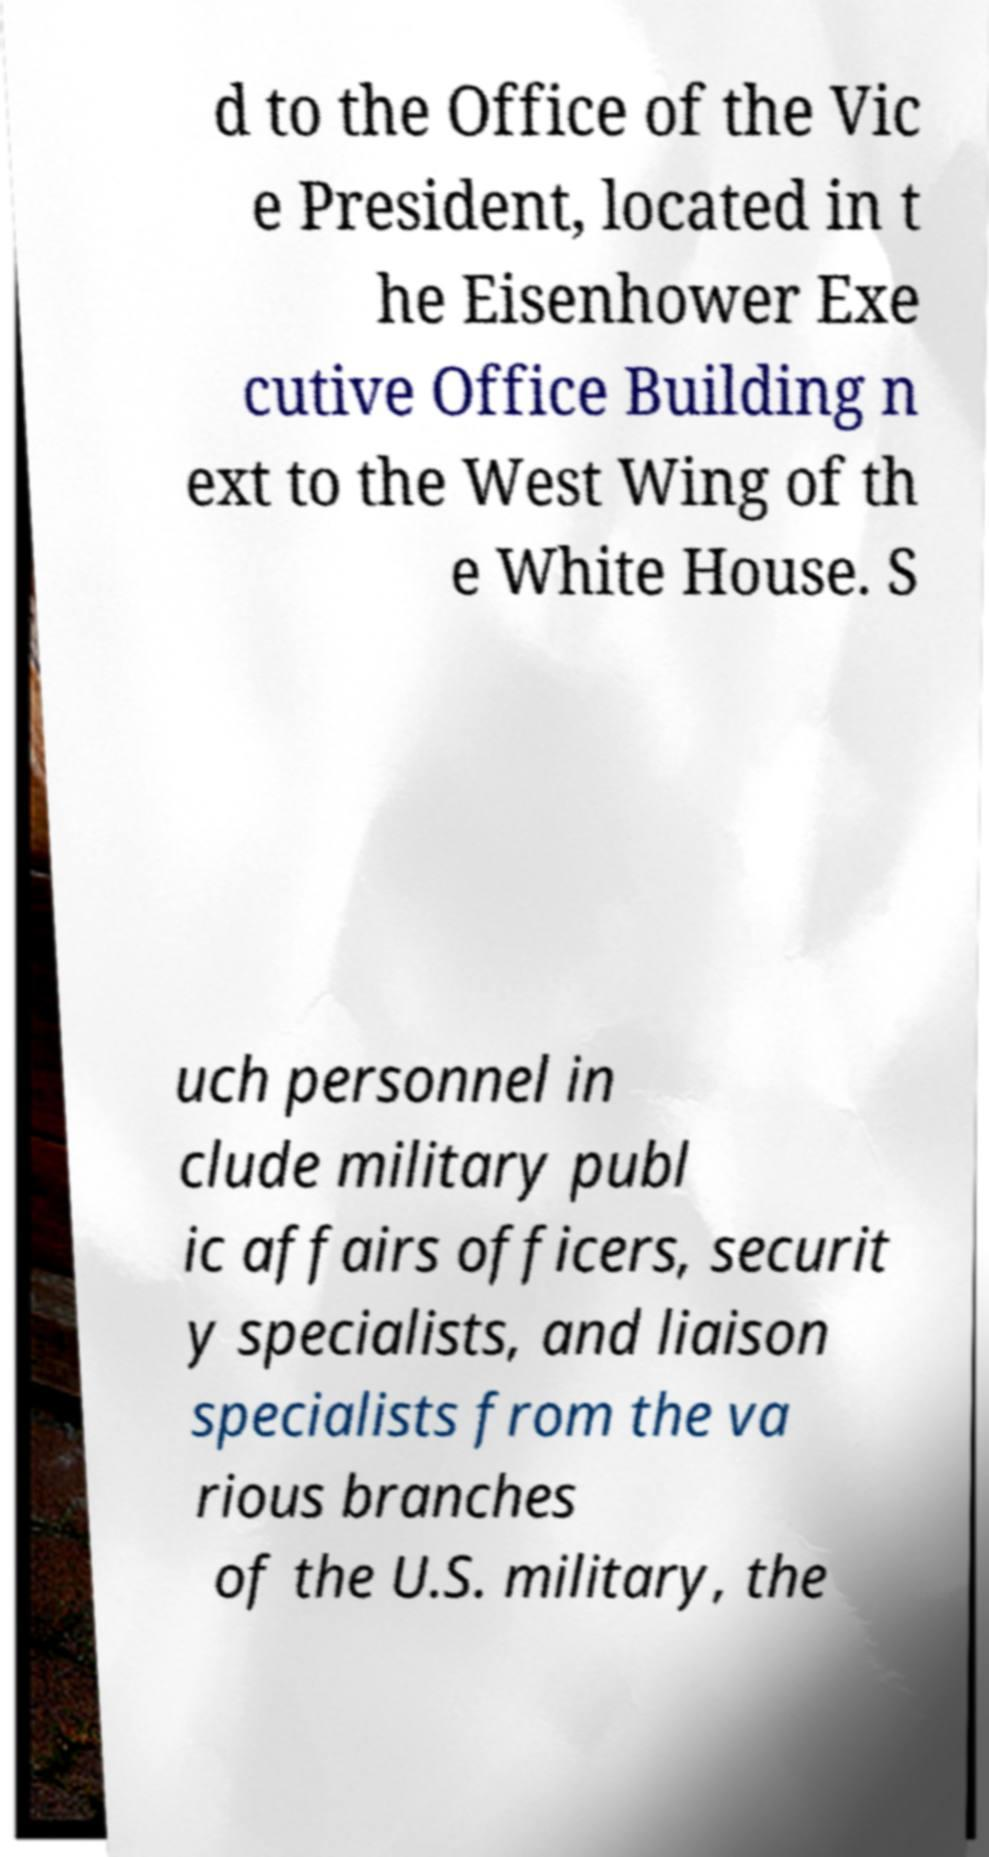What messages or text are displayed in this image? I need them in a readable, typed format. d to the Office of the Vic e President, located in t he Eisenhower Exe cutive Office Building n ext to the West Wing of th e White House. S uch personnel in clude military publ ic affairs officers, securit y specialists, and liaison specialists from the va rious branches of the U.S. military, the 